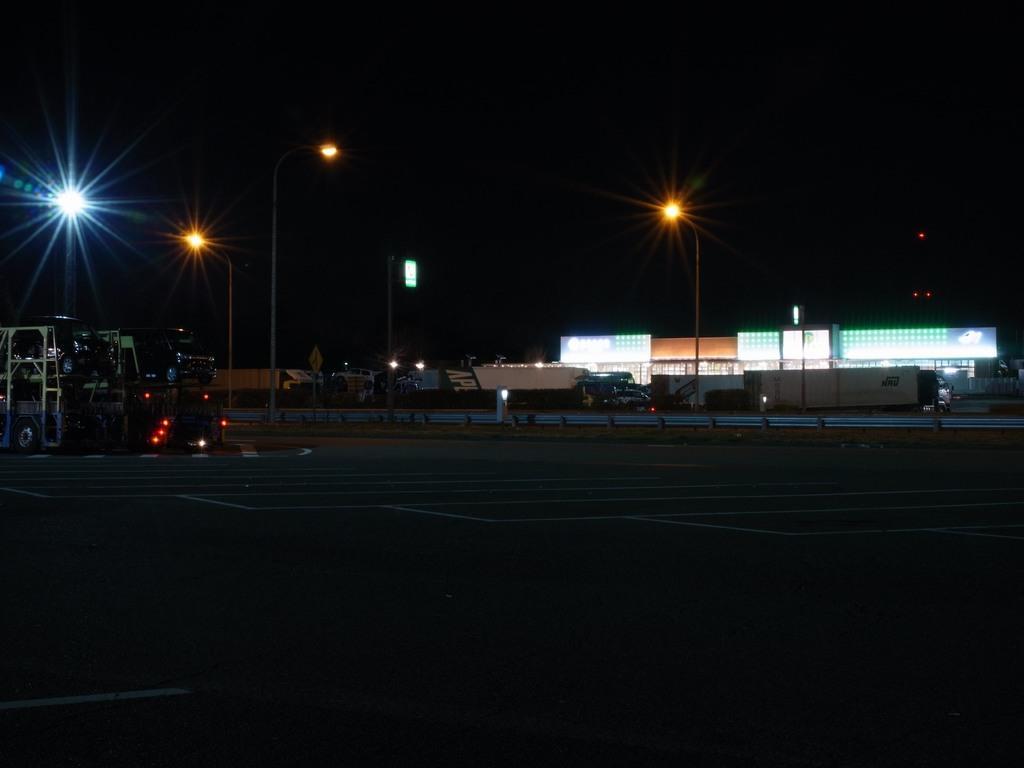How would you summarize this image in a sentence or two? In this image there is a road. in the background there are vehicles, buildings, poles, sign boards. 